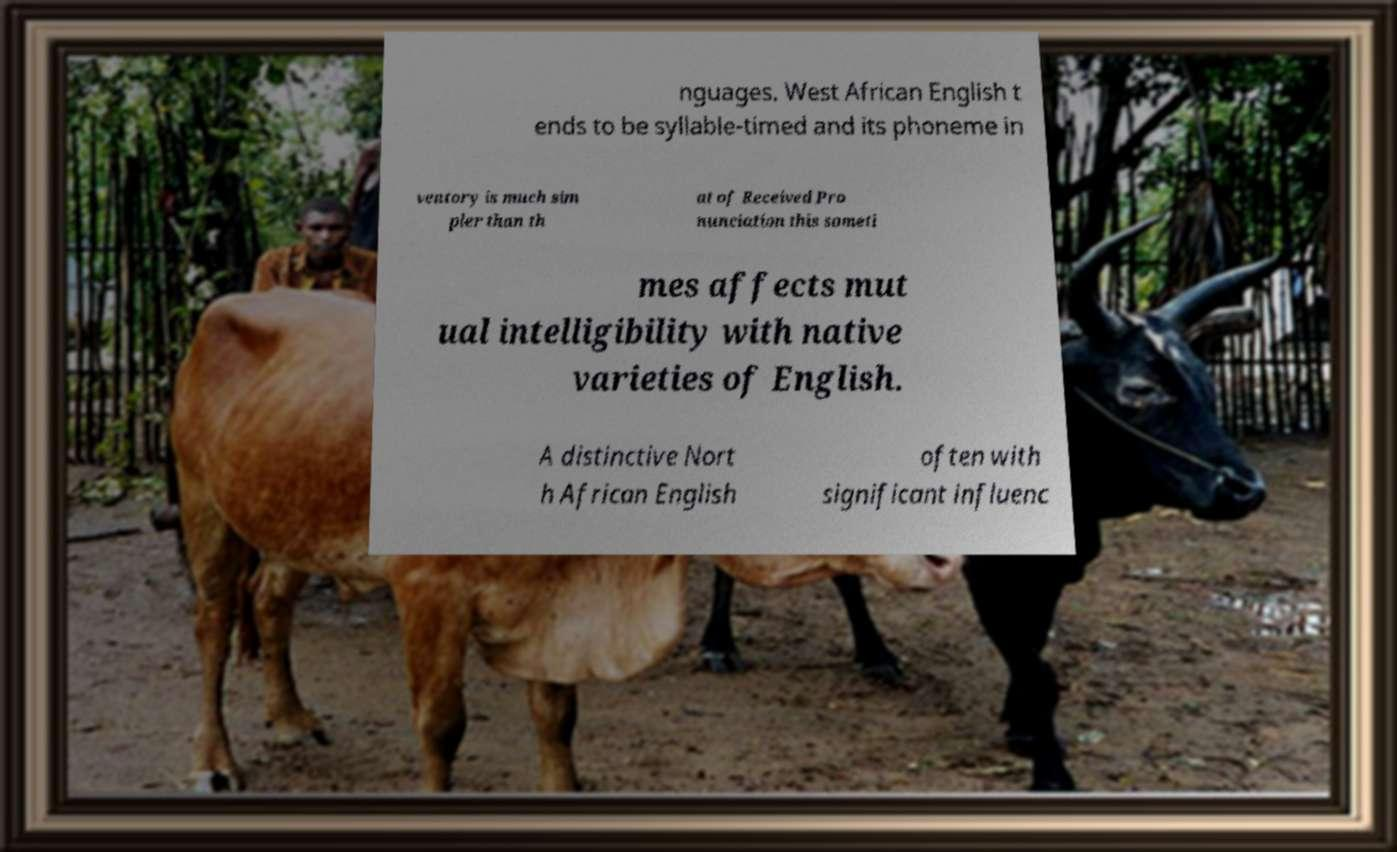I need the written content from this picture converted into text. Can you do that? nguages. West African English t ends to be syllable-timed and its phoneme in ventory is much sim pler than th at of Received Pro nunciation this someti mes affects mut ual intelligibility with native varieties of English. A distinctive Nort h African English often with significant influenc 